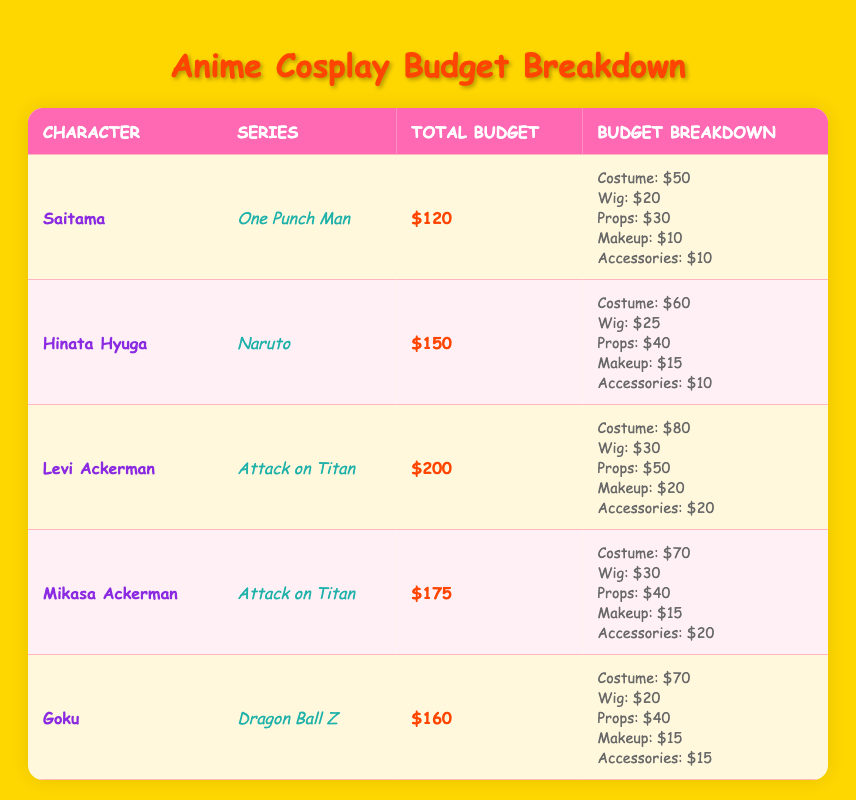What is the total budget for Goku's cosplay? From the table, we can see that the total budget for Goku is listed directly in the Total Budget column as $160.
Answer: $160 Which character has the highest individual costume cost? By looking at the Costume costs in the Breakdown column, Levi Ackerman has the highest individual costume cost at $80, compared to others like Saitama at $50 and Hinata Hyuga at $60.
Answer: Levi Ackerman How much more does the total budget for Levi Ackerman compare to Mikasa Ackerman? Levi Ackerman's total budget is $200 and Mikasa Ackerman's total budget is $175. The difference is calculated as $200 - $175 = $25.
Answer: $25 Is the total budget for Hinata Hyuga higher than that for Saitama? The table shows that Hinata Hyuga's total budget is $150 and Saitama's total budget is $120. Therefore, yes, Hinata's budget is higher.
Answer: Yes What is the average budget for cosplaying the characters from Attack on Titan? Levi Ackerman's budget is $200 and Mikasa Ackerman's budget is $175. Adding these together gives $200 + $175 = $375. We have 2 characters, so the average is $375 / 2 = $187.50.
Answer: $187.50 Which character's cosplay has the least spent on Makeup? By examining the Makeup amounts in the Breakdown column, Saitama has spent $10 on Makeup, which is the least compared to others where the amounts range from $10 to $20.
Answer: Saitama Which series has the character with the most expensive props? Reviewing the Props costs in the Breakdown, Levi Ackerman has the most expensive props at $50, which is higher than any other character listed. Therefore, the series is Attack on Titan.
Answer: Attack on Titan If you combine the total budgets for all characters from Attack on Titan, what would that total be? The total budgets for Levi Ackerman and Mikasa Ackerman are $200 and $175 respectively. When combined, $200 + $175 = $375 is the total budget for both characters.
Answer: $375 Is there any character with a total budget of exactly $150? Yes, Hinata Hyuga has a total budget of $150 according to the table.
Answer: Yes 